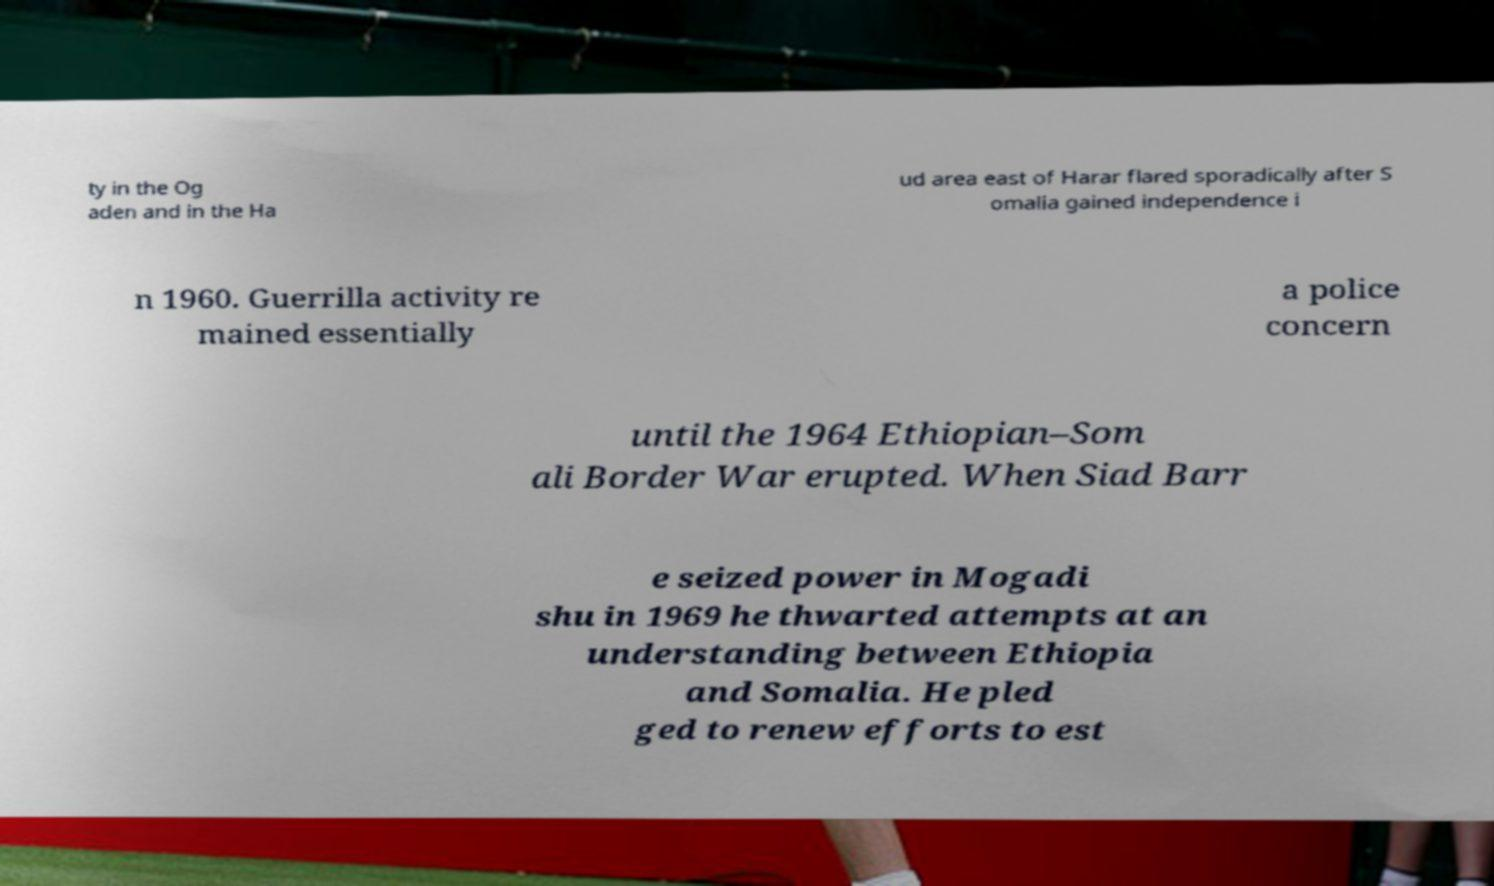Please identify and transcribe the text found in this image. ty in the Og aden and in the Ha ud area east of Harar flared sporadically after S omalia gained independence i n 1960. Guerrilla activity re mained essentially a police concern until the 1964 Ethiopian–Som ali Border War erupted. When Siad Barr e seized power in Mogadi shu in 1969 he thwarted attempts at an understanding between Ethiopia and Somalia. He pled ged to renew efforts to est 